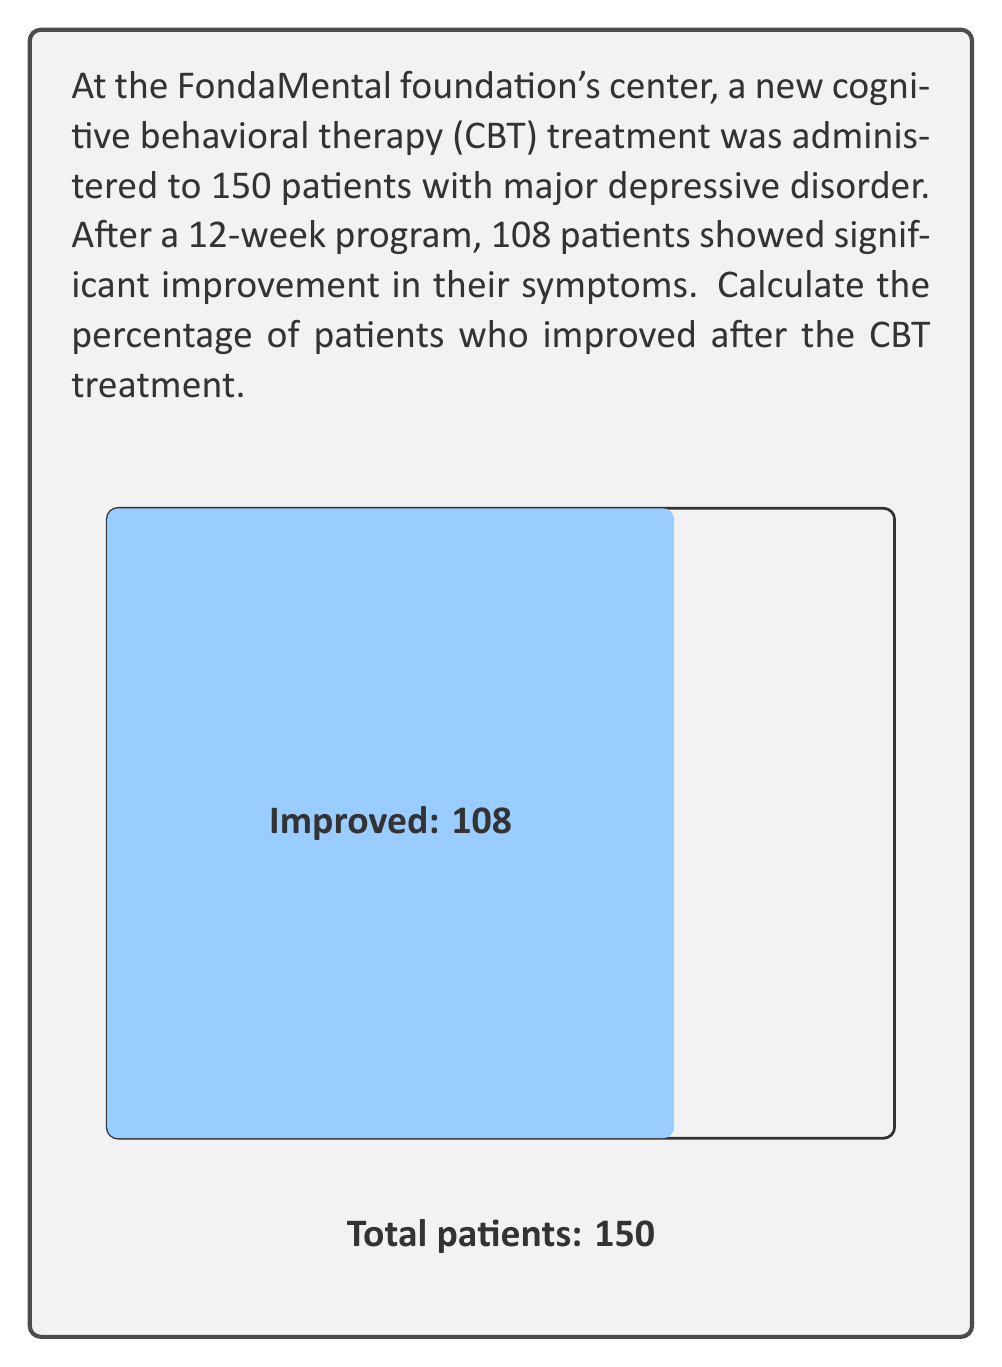Show me your answer to this math problem. To calculate the percentage of patients showing improvement, we need to:

1. Identify the total number of patients and the number who improved:
   - Total patients: $n = 150$
   - Patients who improved: $i = 108$

2. Use the formula for percentage:
   $$ \text{Percentage} = \frac{\text{Part}}{\text{Whole}} \times 100\% $$

3. Plug in our values:
   $$ \text{Percentage improved} = \frac{i}{n} \times 100\% = \frac{108}{150} \times 100\% $$

4. Simplify the fraction:
   $$ \frac{108}{150} = \frac{72}{100} = 0.72 $$

5. Convert to percentage:
   $$ 0.72 \times 100\% = 72\% $$

Therefore, 72% of patients showed improvement after the CBT treatment.
Answer: 72% 